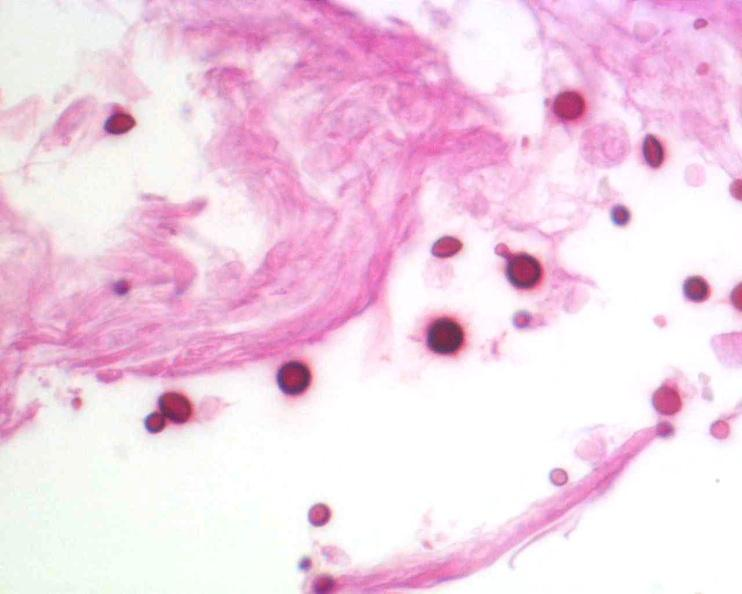does hepatobiliary show brain, cryptococcal meningitis, pas stain?
Answer the question using a single word or phrase. No 